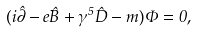<formula> <loc_0><loc_0><loc_500><loc_500>( i \hat { \partial } - e \hat { B } + \gamma ^ { 5 } \hat { D } - m ) \Phi = 0 ,</formula> 